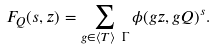Convert formula to latex. <formula><loc_0><loc_0><loc_500><loc_500>F _ { Q } ( s , z ) = \sum _ { g \in \langle T \rangle \ \Gamma } \phi ( g z , g Q ) ^ { s } .</formula> 